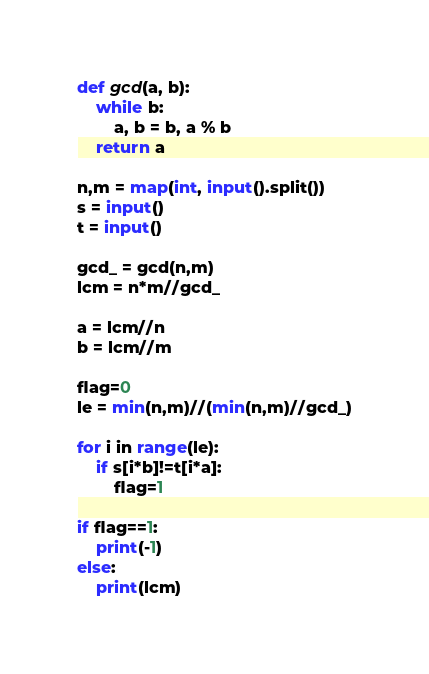<code> <loc_0><loc_0><loc_500><loc_500><_Python_>def gcd(a, b):
	while b:
		a, b = b, a % b
	return a

n,m = map(int, input().split())
s = input()
t = input()

gcd_ = gcd(n,m)
lcm = n*m//gcd_

a = lcm//n
b = lcm//m

flag=0
le = min(n,m)//(min(n,m)//gcd_)

for i in range(le):
    if s[i*b]!=t[i*a]:
        flag=1

if flag==1:
    print(-1)
else:
    print(lcm)</code> 